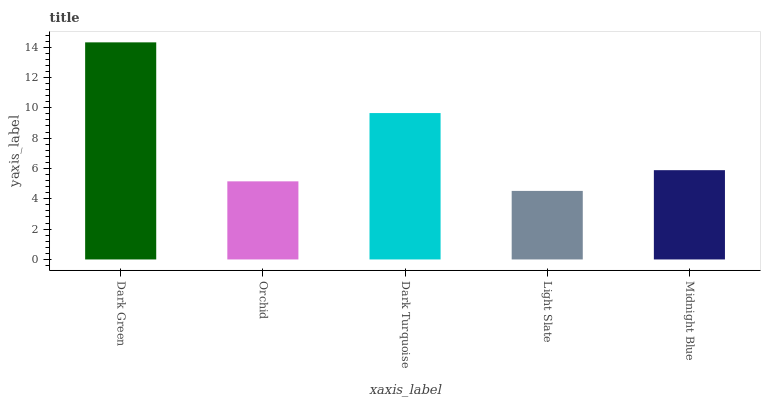Is Orchid the minimum?
Answer yes or no. No. Is Orchid the maximum?
Answer yes or no. No. Is Dark Green greater than Orchid?
Answer yes or no. Yes. Is Orchid less than Dark Green?
Answer yes or no. Yes. Is Orchid greater than Dark Green?
Answer yes or no. No. Is Dark Green less than Orchid?
Answer yes or no. No. Is Midnight Blue the high median?
Answer yes or no. Yes. Is Midnight Blue the low median?
Answer yes or no. Yes. Is Dark Turquoise the high median?
Answer yes or no. No. Is Dark Green the low median?
Answer yes or no. No. 